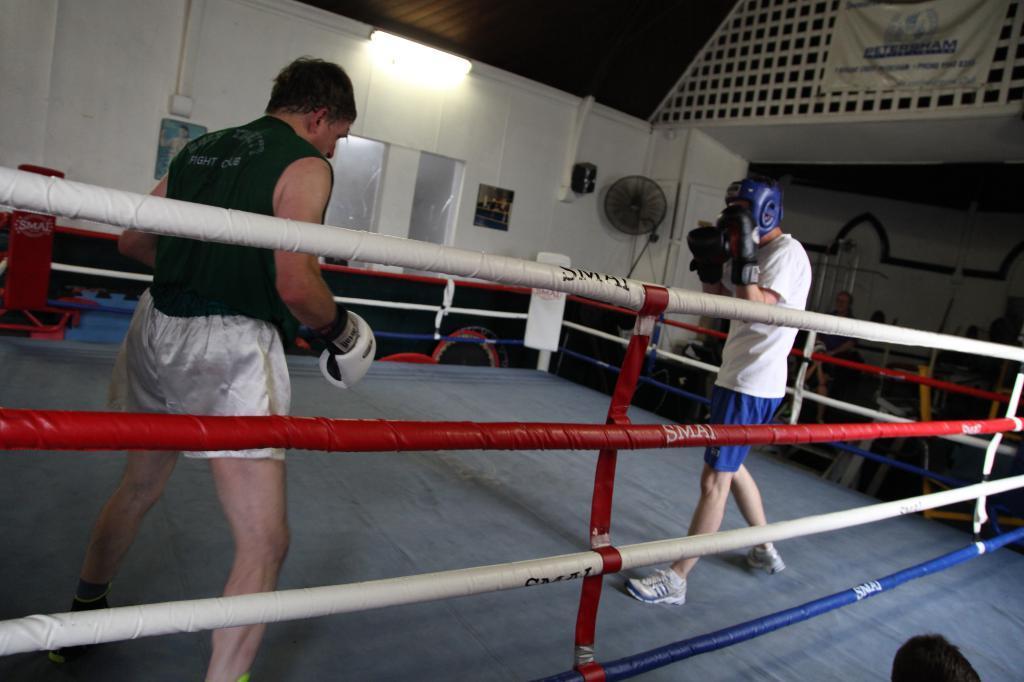Describe this image in one or two sentences. In this picture we can see group of people, two people wore gloves, beside them we can find ropes, in the background we can see a fan, light and a flex. 